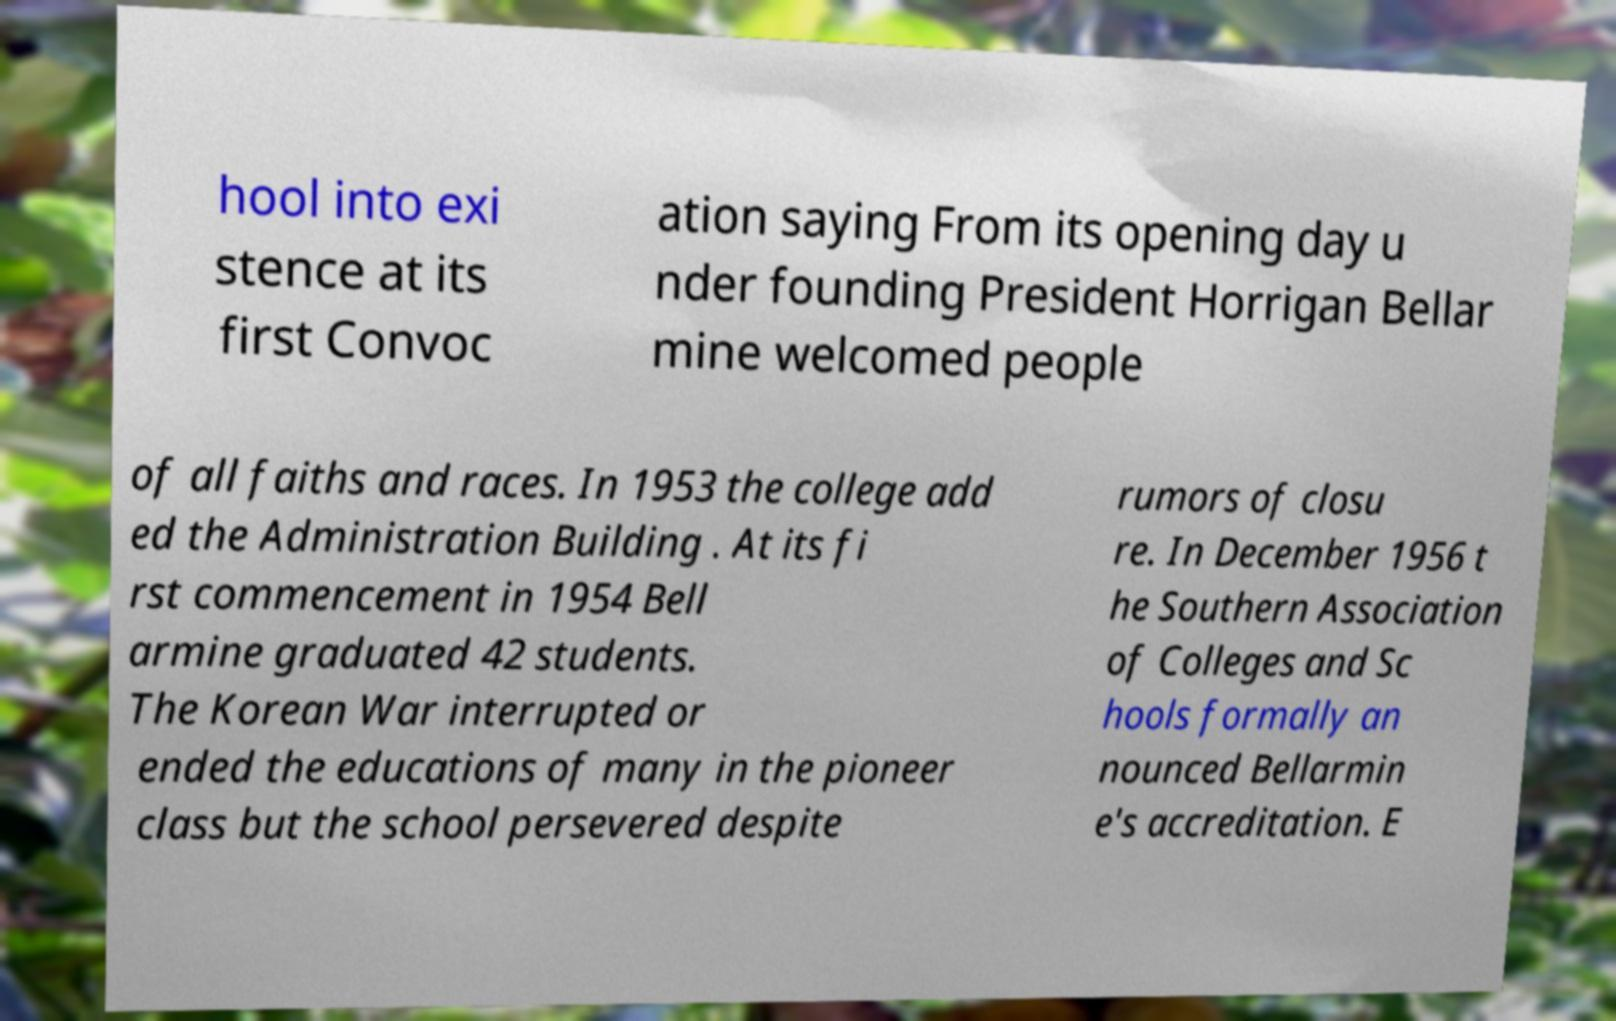Could you extract and type out the text from this image? hool into exi stence at its first Convoc ation saying From its opening day u nder founding President Horrigan Bellar mine welcomed people of all faiths and races. In 1953 the college add ed the Administration Building . At its fi rst commencement in 1954 Bell armine graduated 42 students. The Korean War interrupted or ended the educations of many in the pioneer class but the school persevered despite rumors of closu re. In December 1956 t he Southern Association of Colleges and Sc hools formally an nounced Bellarmin e's accreditation. E 